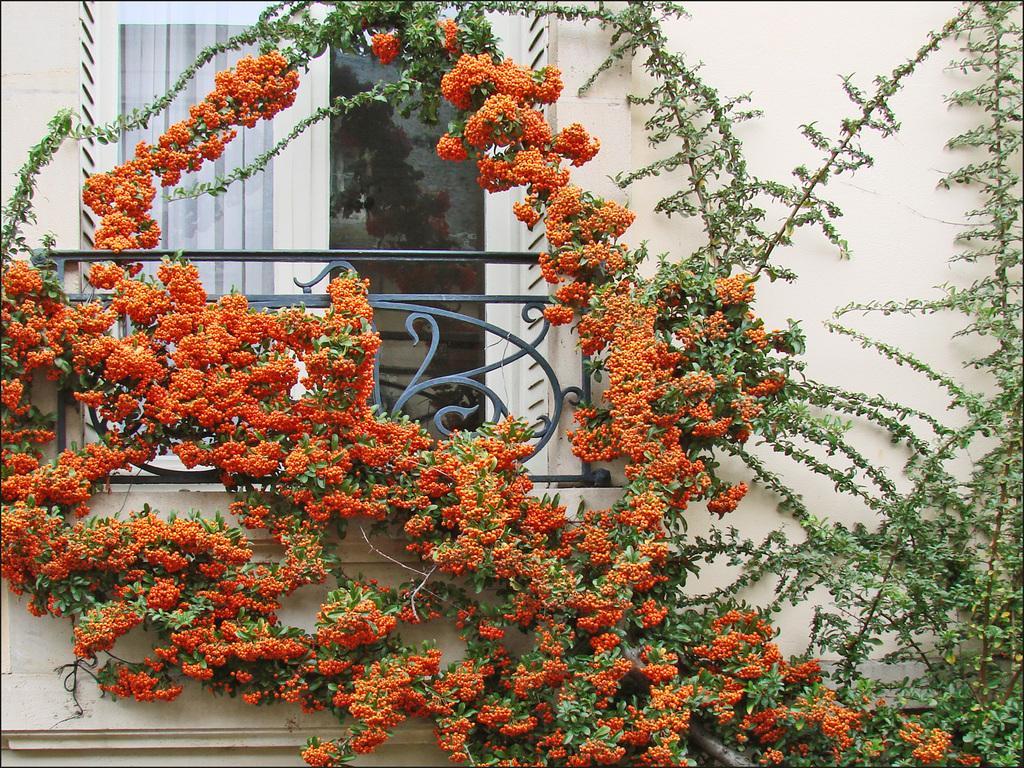Could you give a brief overview of what you see in this image? In this image I can see a window, a railing, the wall and in the front of the wall I can see plants and orange colour of flowers. 